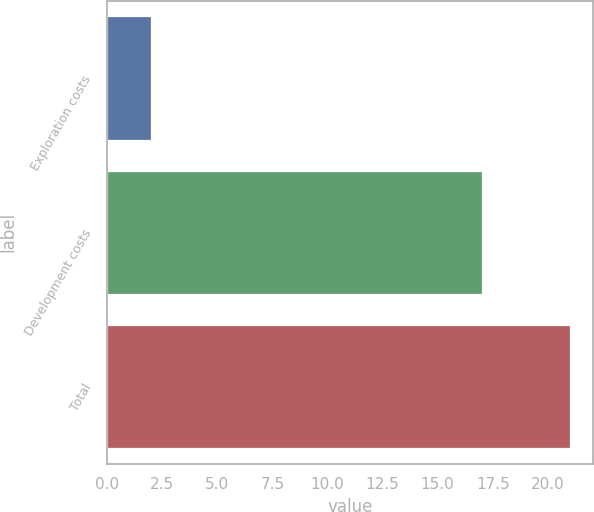Convert chart to OTSL. <chart><loc_0><loc_0><loc_500><loc_500><bar_chart><fcel>Exploration costs<fcel>Development costs<fcel>Total<nl><fcel>2<fcel>17<fcel>21<nl></chart> 